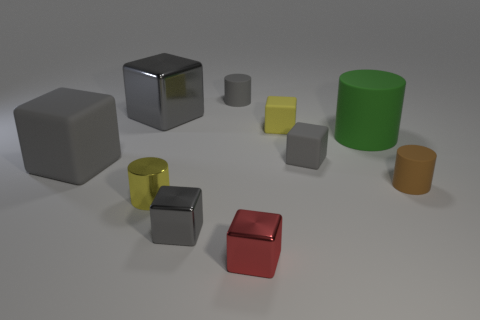How many gray cubes must be subtracted to get 2 gray cubes? 2 Subtract all brown cylinders. How many gray blocks are left? 4 Subtract 1 cylinders. How many cylinders are left? 3 Subtract all yellow blocks. How many blocks are left? 5 Subtract all large gray metal cubes. How many cubes are left? 5 Subtract all purple blocks. Subtract all gray cylinders. How many blocks are left? 6 Subtract all blocks. How many objects are left? 4 Add 4 tiny blue rubber objects. How many tiny blue rubber objects exist? 4 Subtract 0 red spheres. How many objects are left? 10 Subtract all small blue metal cylinders. Subtract all large metal blocks. How many objects are left? 9 